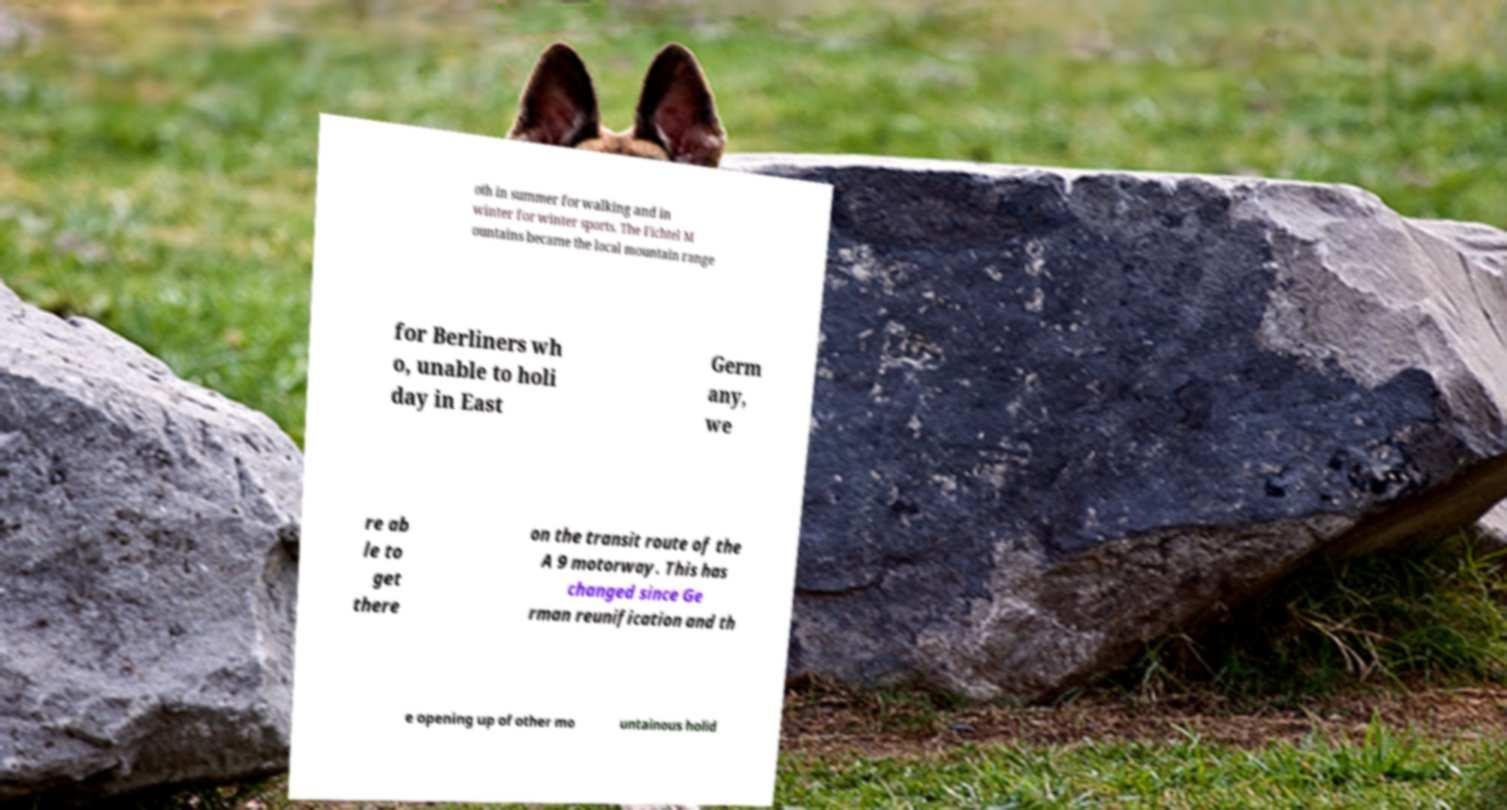Could you extract and type out the text from this image? oth in summer for walking and in winter for winter sports. The Fichtel M ountains became the local mountain range for Berliners wh o, unable to holi day in East Germ any, we re ab le to get there on the transit route of the A 9 motorway. This has changed since Ge rman reunification and th e opening up of other mo untainous holid 